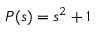<formula> <loc_0><loc_0><loc_500><loc_500>P ( s ) = s ^ { 2 } + 1</formula> 